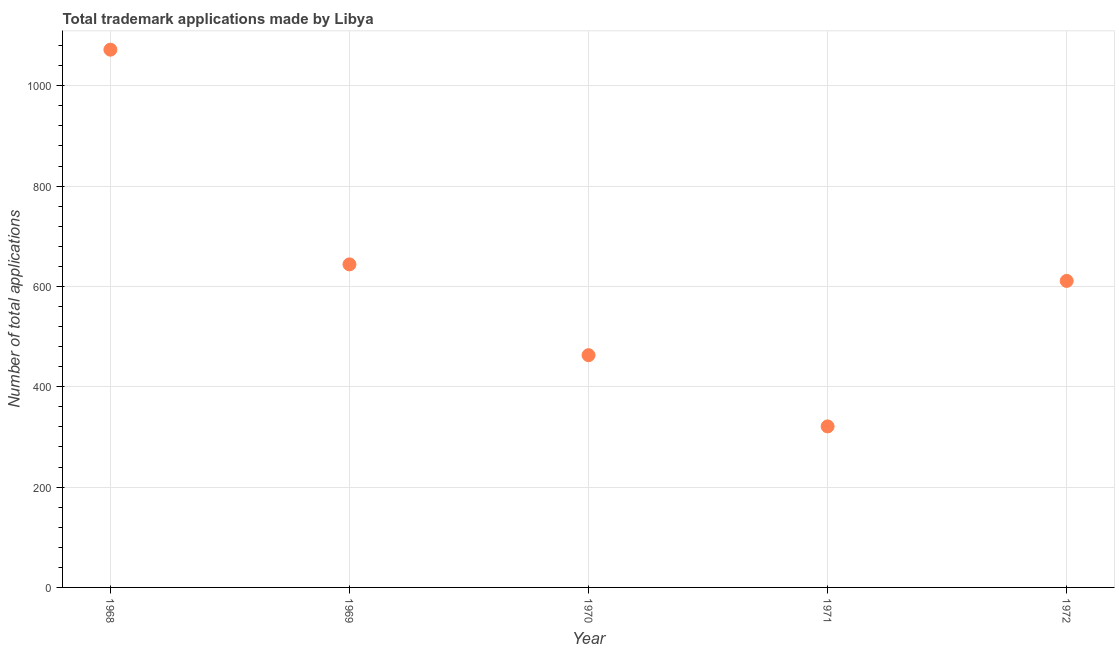What is the number of trademark applications in 1972?
Your answer should be very brief. 611. Across all years, what is the maximum number of trademark applications?
Provide a short and direct response. 1072. Across all years, what is the minimum number of trademark applications?
Provide a short and direct response. 321. In which year was the number of trademark applications maximum?
Give a very brief answer. 1968. What is the sum of the number of trademark applications?
Provide a succinct answer. 3111. What is the difference between the number of trademark applications in 1968 and 1970?
Make the answer very short. 609. What is the average number of trademark applications per year?
Give a very brief answer. 622.2. What is the median number of trademark applications?
Offer a terse response. 611. In how many years, is the number of trademark applications greater than 880 ?
Keep it short and to the point. 1. What is the ratio of the number of trademark applications in 1969 to that in 1972?
Your answer should be compact. 1.05. What is the difference between the highest and the second highest number of trademark applications?
Your answer should be very brief. 428. Is the sum of the number of trademark applications in 1968 and 1971 greater than the maximum number of trademark applications across all years?
Offer a terse response. Yes. What is the difference between the highest and the lowest number of trademark applications?
Ensure brevity in your answer.  751. How many years are there in the graph?
Give a very brief answer. 5. Are the values on the major ticks of Y-axis written in scientific E-notation?
Ensure brevity in your answer.  No. Does the graph contain any zero values?
Offer a very short reply. No. Does the graph contain grids?
Your response must be concise. Yes. What is the title of the graph?
Your response must be concise. Total trademark applications made by Libya. What is the label or title of the Y-axis?
Your response must be concise. Number of total applications. What is the Number of total applications in 1968?
Offer a terse response. 1072. What is the Number of total applications in 1969?
Provide a succinct answer. 644. What is the Number of total applications in 1970?
Keep it short and to the point. 463. What is the Number of total applications in 1971?
Your response must be concise. 321. What is the Number of total applications in 1972?
Your response must be concise. 611. What is the difference between the Number of total applications in 1968 and 1969?
Provide a short and direct response. 428. What is the difference between the Number of total applications in 1968 and 1970?
Your response must be concise. 609. What is the difference between the Number of total applications in 1968 and 1971?
Your answer should be very brief. 751. What is the difference between the Number of total applications in 1968 and 1972?
Your answer should be compact. 461. What is the difference between the Number of total applications in 1969 and 1970?
Ensure brevity in your answer.  181. What is the difference between the Number of total applications in 1969 and 1971?
Your answer should be very brief. 323. What is the difference between the Number of total applications in 1969 and 1972?
Provide a short and direct response. 33. What is the difference between the Number of total applications in 1970 and 1971?
Offer a terse response. 142. What is the difference between the Number of total applications in 1970 and 1972?
Offer a terse response. -148. What is the difference between the Number of total applications in 1971 and 1972?
Offer a terse response. -290. What is the ratio of the Number of total applications in 1968 to that in 1969?
Ensure brevity in your answer.  1.67. What is the ratio of the Number of total applications in 1968 to that in 1970?
Provide a succinct answer. 2.31. What is the ratio of the Number of total applications in 1968 to that in 1971?
Your answer should be compact. 3.34. What is the ratio of the Number of total applications in 1968 to that in 1972?
Make the answer very short. 1.75. What is the ratio of the Number of total applications in 1969 to that in 1970?
Keep it short and to the point. 1.39. What is the ratio of the Number of total applications in 1969 to that in 1971?
Your response must be concise. 2.01. What is the ratio of the Number of total applications in 1969 to that in 1972?
Give a very brief answer. 1.05. What is the ratio of the Number of total applications in 1970 to that in 1971?
Offer a terse response. 1.44. What is the ratio of the Number of total applications in 1970 to that in 1972?
Ensure brevity in your answer.  0.76. What is the ratio of the Number of total applications in 1971 to that in 1972?
Offer a terse response. 0.53. 